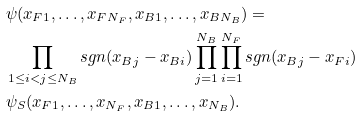Convert formula to latex. <formula><loc_0><loc_0><loc_500><loc_500>& \psi ( x _ { F 1 } , \dots , x _ { F N _ { F } } , x _ { B 1 } , \dots , x _ { B N _ { B } } ) = \\ & \prod _ { 1 \leq i < j \leq N _ { B } } s g n ( x _ { B j } - x _ { B i } ) \prod _ { j = 1 } ^ { N _ { B } } \prod _ { i = 1 } ^ { N _ { F } } s g n ( x _ { B j } - x _ { F i } ) \\ & \psi _ { S } ( x _ { F 1 } , \dots , x _ { N _ { F } } , x _ { B 1 } , \dots , x _ { N _ { B } } ) .</formula> 